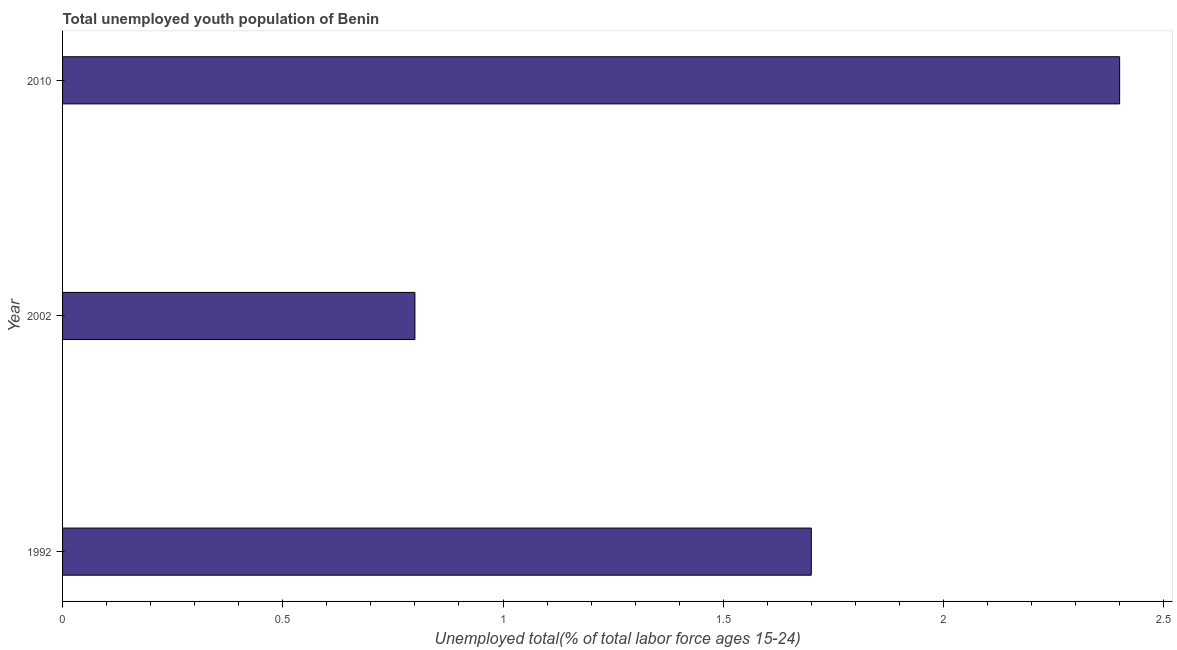Does the graph contain any zero values?
Your answer should be very brief. No. What is the title of the graph?
Provide a succinct answer. Total unemployed youth population of Benin. What is the label or title of the X-axis?
Your response must be concise. Unemployed total(% of total labor force ages 15-24). What is the label or title of the Y-axis?
Your answer should be very brief. Year. What is the unemployed youth in 2002?
Ensure brevity in your answer.  0.8. Across all years, what is the maximum unemployed youth?
Your answer should be compact. 2.4. Across all years, what is the minimum unemployed youth?
Provide a short and direct response. 0.8. In which year was the unemployed youth maximum?
Ensure brevity in your answer.  2010. In which year was the unemployed youth minimum?
Keep it short and to the point. 2002. What is the sum of the unemployed youth?
Your answer should be compact. 4.9. What is the difference between the unemployed youth in 1992 and 2002?
Your answer should be very brief. 0.9. What is the average unemployed youth per year?
Provide a short and direct response. 1.63. What is the median unemployed youth?
Offer a very short reply. 1.7. Do a majority of the years between 2002 and 1992 (inclusive) have unemployed youth greater than 1.9 %?
Offer a very short reply. No. What is the ratio of the unemployed youth in 2002 to that in 2010?
Your response must be concise. 0.33. Is the difference between the unemployed youth in 1992 and 2002 greater than the difference between any two years?
Your answer should be very brief. No. Is the sum of the unemployed youth in 1992 and 2010 greater than the maximum unemployed youth across all years?
Offer a terse response. Yes. What is the difference between the highest and the lowest unemployed youth?
Offer a very short reply. 1.6. In how many years, is the unemployed youth greater than the average unemployed youth taken over all years?
Provide a succinct answer. 2. How many years are there in the graph?
Make the answer very short. 3. What is the difference between two consecutive major ticks on the X-axis?
Your answer should be compact. 0.5. Are the values on the major ticks of X-axis written in scientific E-notation?
Your answer should be very brief. No. What is the Unemployed total(% of total labor force ages 15-24) of 1992?
Ensure brevity in your answer.  1.7. What is the Unemployed total(% of total labor force ages 15-24) in 2002?
Keep it short and to the point. 0.8. What is the Unemployed total(% of total labor force ages 15-24) in 2010?
Ensure brevity in your answer.  2.4. What is the difference between the Unemployed total(% of total labor force ages 15-24) in 1992 and 2002?
Keep it short and to the point. 0.9. What is the ratio of the Unemployed total(% of total labor force ages 15-24) in 1992 to that in 2002?
Your answer should be compact. 2.12. What is the ratio of the Unemployed total(% of total labor force ages 15-24) in 1992 to that in 2010?
Make the answer very short. 0.71. What is the ratio of the Unemployed total(% of total labor force ages 15-24) in 2002 to that in 2010?
Provide a succinct answer. 0.33. 